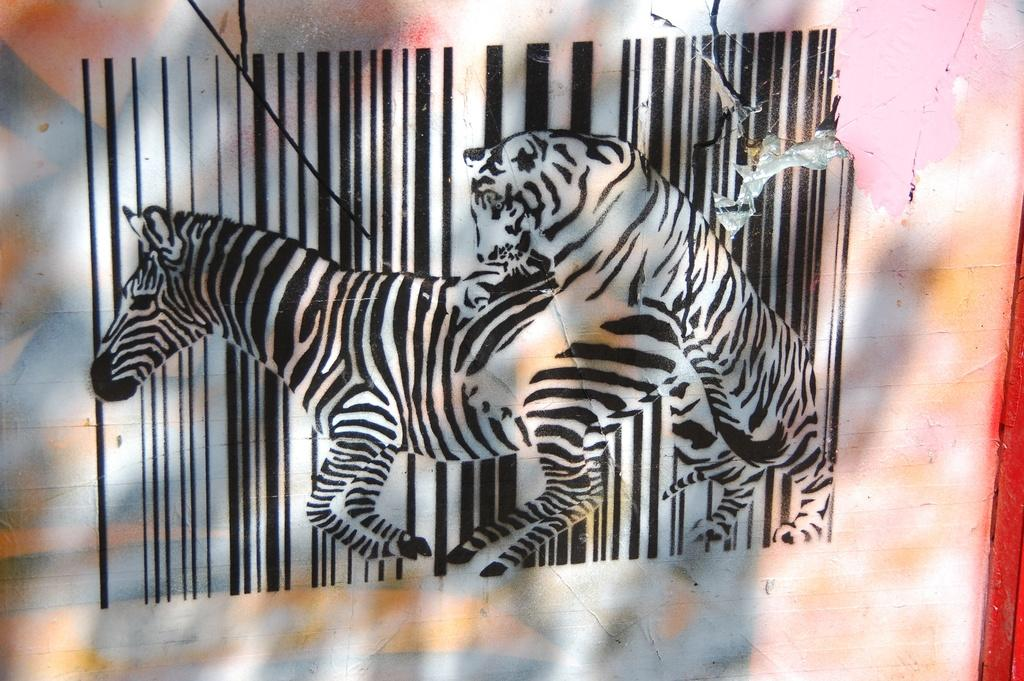What is depicted on the wall in the image? There are animals painted on the wall in the image. What type of voice can be heard coming from the animals in the image? There are no voices present in the image, as it is a painting of animals on a wall. 